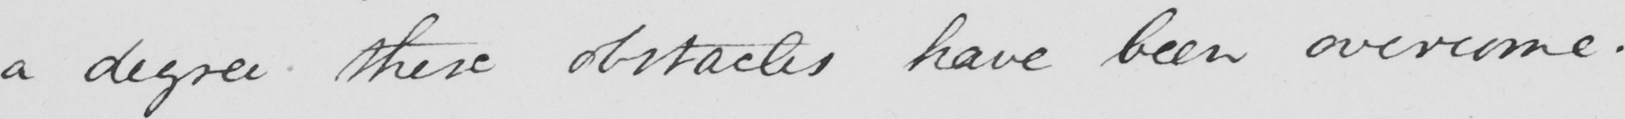Please provide the text content of this handwritten line. a degree these obstacles have been overcome . 